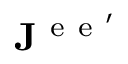<formula> <loc_0><loc_0><loc_500><loc_500>J ^ { e e ^ { \prime } }</formula> 